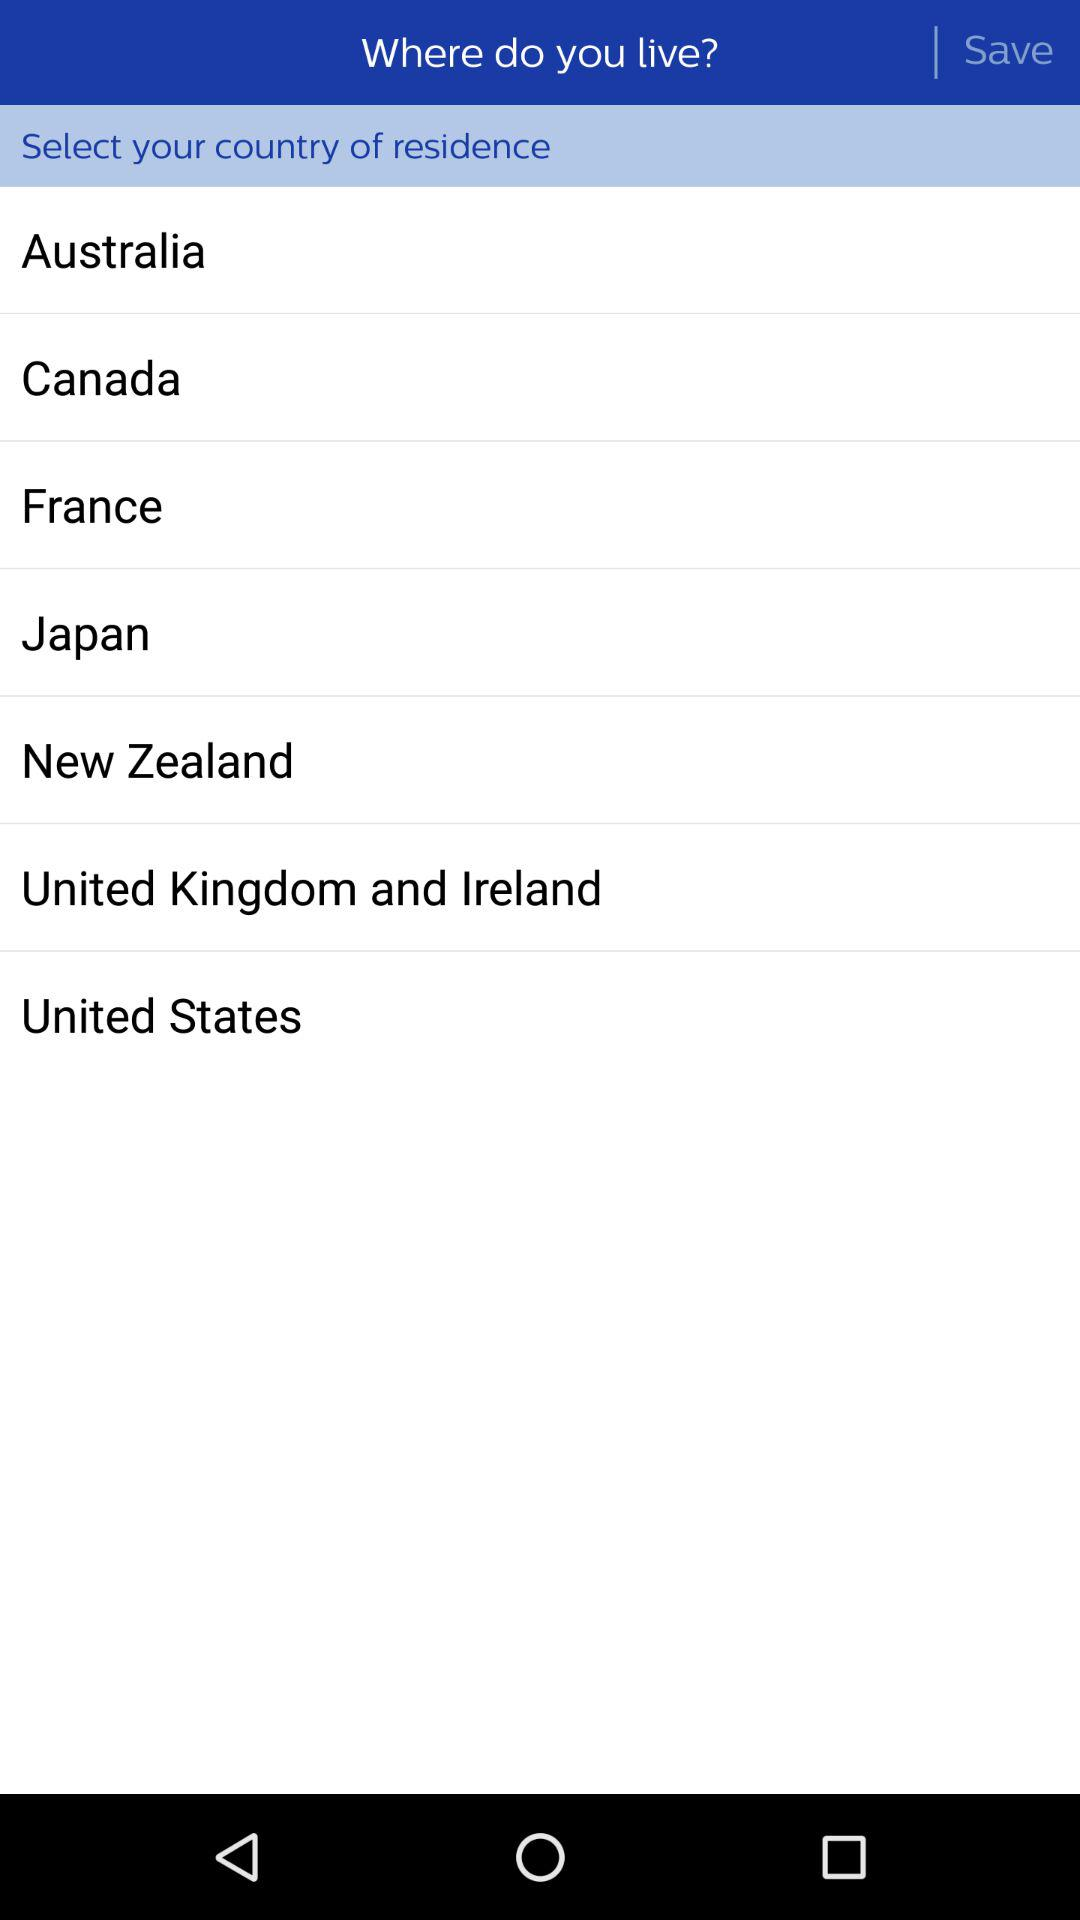How many countries are available to select from?
Answer the question using a single word or phrase. 7 